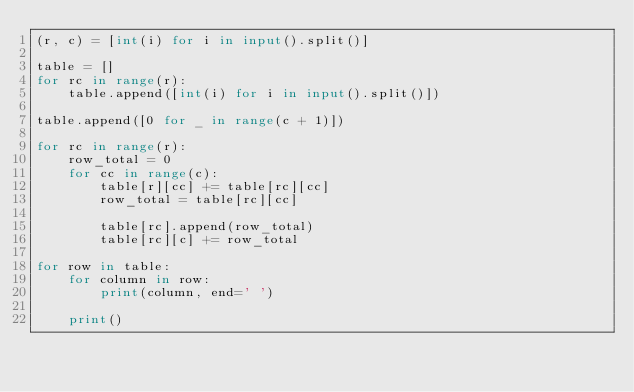<code> <loc_0><loc_0><loc_500><loc_500><_Python_>(r, c) = [int(i) for i in input().split()]

table = []
for rc in range(r):
    table.append([int(i) for i in input().split()])

table.append([0 for _ in range(c + 1)])

for rc in range(r):
    row_total = 0 
    for cc in range(c):
        table[r][cc] += table[rc][cc]
        row_total = table[rc][cc]

        table[rc].append(row_total)
        table[rc][c] += row_total

for row in table:
    for column in row:
        print(column, end=' ')

    print()</code> 